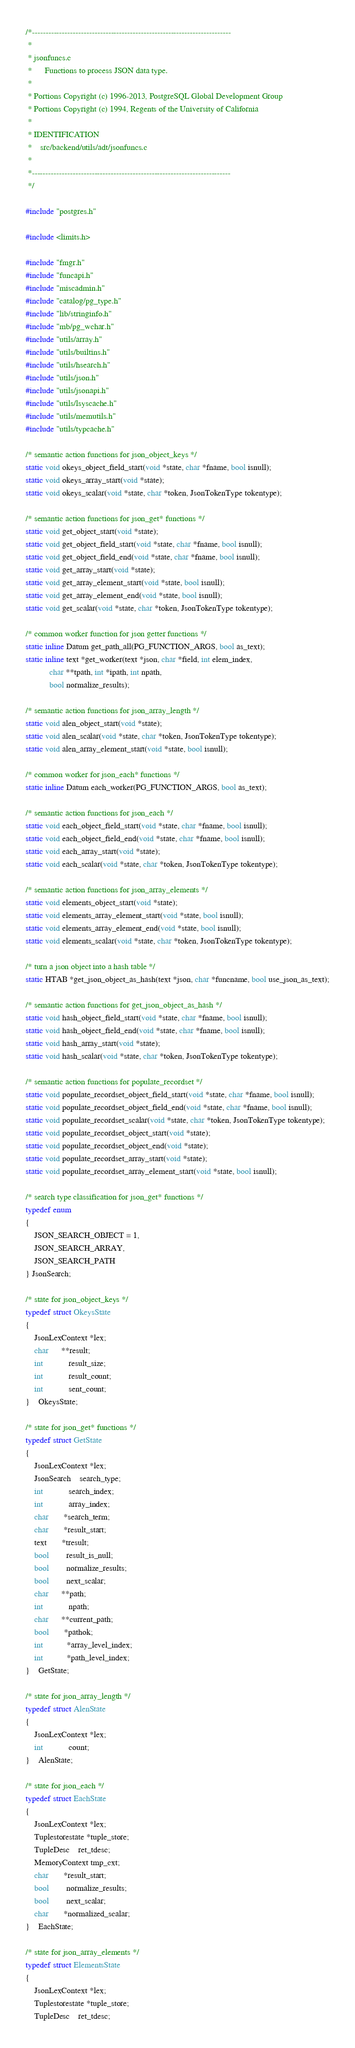<code> <loc_0><loc_0><loc_500><loc_500><_C_>/*-------------------------------------------------------------------------
 *
 * jsonfuncs.c
 *		Functions to process JSON data type.
 *
 * Portions Copyright (c) 1996-2013, PostgreSQL Global Development Group
 * Portions Copyright (c) 1994, Regents of the University of California
 *
 * IDENTIFICATION
 *	  src/backend/utils/adt/jsonfuncs.c
 *
 *-------------------------------------------------------------------------
 */

#include "postgres.h"

#include <limits.h>

#include "fmgr.h"
#include "funcapi.h"
#include "miscadmin.h"
#include "catalog/pg_type.h"
#include "lib/stringinfo.h"
#include "mb/pg_wchar.h"
#include "utils/array.h"
#include "utils/builtins.h"
#include "utils/hsearch.h"
#include "utils/json.h"
#include "utils/jsonapi.h"
#include "utils/lsyscache.h"
#include "utils/memutils.h"
#include "utils/typcache.h"

/* semantic action functions for json_object_keys */
static void okeys_object_field_start(void *state, char *fname, bool isnull);
static void okeys_array_start(void *state);
static void okeys_scalar(void *state, char *token, JsonTokenType tokentype);

/* semantic action functions for json_get* functions */
static void get_object_start(void *state);
static void get_object_field_start(void *state, char *fname, bool isnull);
static void get_object_field_end(void *state, char *fname, bool isnull);
static void get_array_start(void *state);
static void get_array_element_start(void *state, bool isnull);
static void get_array_element_end(void *state, bool isnull);
static void get_scalar(void *state, char *token, JsonTokenType tokentype);

/* common worker function for json getter functions */
static inline Datum get_path_all(PG_FUNCTION_ARGS, bool as_text);
static inline text *get_worker(text *json, char *field, int elem_index,
		   char **tpath, int *ipath, int npath,
		   bool normalize_results);

/* semantic action functions for json_array_length */
static void alen_object_start(void *state);
static void alen_scalar(void *state, char *token, JsonTokenType tokentype);
static void alen_array_element_start(void *state, bool isnull);

/* common worker for json_each* functions */
static inline Datum each_worker(PG_FUNCTION_ARGS, bool as_text);

/* semantic action functions for json_each */
static void each_object_field_start(void *state, char *fname, bool isnull);
static void each_object_field_end(void *state, char *fname, bool isnull);
static void each_array_start(void *state);
static void each_scalar(void *state, char *token, JsonTokenType tokentype);

/* semantic action functions for json_array_elements */
static void elements_object_start(void *state);
static void elements_array_element_start(void *state, bool isnull);
static void elements_array_element_end(void *state, bool isnull);
static void elements_scalar(void *state, char *token, JsonTokenType tokentype);

/* turn a json object into a hash table */
static HTAB *get_json_object_as_hash(text *json, char *funcname, bool use_json_as_text);

/* semantic action functions for get_json_object_as_hash */
static void hash_object_field_start(void *state, char *fname, bool isnull);
static void hash_object_field_end(void *state, char *fname, bool isnull);
static void hash_array_start(void *state);
static void hash_scalar(void *state, char *token, JsonTokenType tokentype);

/* semantic action functions for populate_recordset */
static void populate_recordset_object_field_start(void *state, char *fname, bool isnull);
static void populate_recordset_object_field_end(void *state, char *fname, bool isnull);
static void populate_recordset_scalar(void *state, char *token, JsonTokenType tokentype);
static void populate_recordset_object_start(void *state);
static void populate_recordset_object_end(void *state);
static void populate_recordset_array_start(void *state);
static void populate_recordset_array_element_start(void *state, bool isnull);

/* search type classification for json_get* functions */
typedef enum
{
	JSON_SEARCH_OBJECT = 1,
	JSON_SEARCH_ARRAY,
	JSON_SEARCH_PATH
} JsonSearch;

/* state for json_object_keys */
typedef struct OkeysState
{
	JsonLexContext *lex;
	char	  **result;
	int			result_size;
	int			result_count;
	int			sent_count;
}	OkeysState;

/* state for json_get* functions */
typedef struct GetState
{
	JsonLexContext *lex;
	JsonSearch	search_type;
	int			search_index;
	int			array_index;
	char	   *search_term;
	char	   *result_start;
	text	   *tresult;
	bool		result_is_null;
	bool		normalize_results;
	bool		next_scalar;
	char	  **path;
	int			npath;
	char	  **current_path;
	bool	   *pathok;
	int		   *array_level_index;
	int		   *path_level_index;
}	GetState;

/* state for json_array_length */
typedef struct AlenState
{
	JsonLexContext *lex;
	int			count;
}	AlenState;

/* state for json_each */
typedef struct EachState
{
	JsonLexContext *lex;
	Tuplestorestate *tuple_store;
	TupleDesc	ret_tdesc;
	MemoryContext tmp_cxt;
	char	   *result_start;
	bool		normalize_results;
	bool		next_scalar;
	char	   *normalized_scalar;
}	EachState;

/* state for json_array_elements */
typedef struct ElementsState
{
	JsonLexContext *lex;
	Tuplestorestate *tuple_store;
	TupleDesc	ret_tdesc;</code> 